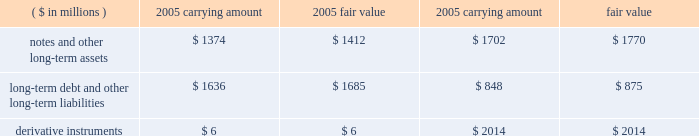Fair value of financial instruments we believe that the fair values of current assets and current liabilities approximate their reported carrying amounts .
The fair values of non-current financial assets , liabilities and derivatives are shown in the table. .
We value notes and other receivables based on the expected future cash flows dis- counted at risk-adjusted rates .
We determine valuations for long-term debt and other long-term liabilities based on quoted market prices or expected future payments dis- counted at risk-adjusted rates .
Derivative instruments during 2003 , we entered into an interest rate swap agreement under which we receive a floating rate of interest and pay a fixed rate of interest .
The swap modifies our interest rate exposure by effectively converting a note receivable with a fixed rate to a floating rate .
The aggregate notional amount of the swap is $ 92 million and it matures in 2010 .
The swap is classified as a fair value hedge under fas no .
133 , 201caccounting for derivative instruments and hedging activities 201d ( 201cfas no .
133 201d ) , and the change in the fair value of the swap , as well as the change in the fair value of the underlying note receivable , is recognized in interest income .
The fair value of the swap was a $ 1 million asset at year-end 2005 , and a $ 3 million liability at year-end 2004 .
The hedge is highly effective , and therefore , no net gain or loss was reported during 2005 , 2004 , and 2003 .
During 2005 , we entered into two interest rate swap agreements to manage the volatil- ity of the u.s .
Treasury component of the interest rate risk associated with the forecasted issuance our series f senior notes and the exchange of our series c and e senior notes for new series g senior notes .
Both swaps were designated as cash flow hedges under fas no .
133 and were terminated upon pricing of the notes .
Both swaps were highly effective in offsetting fluctuations in the u.s .
Treasury component .
Thus , there was no net gain or loss reported in earnings during 2005 .
The total amount for these swaps was recorded in other comprehensive income and was a net loss of $ 2 million during 2005 , which will be amortized to interest expense using the interest method over the life of the notes .
At year-end 2005 , we had six outstanding interest rate swap agreements to manage interest rate risk associated with the residual interests we retain in conjunction with our timeshare note sales .
Historically , we were required by purchasers and/or rating agen- cies to utilize interest rate swaps to protect the excess spread within our sold note pools .
The aggregate notional amount of the swaps is $ 380 million , and they expire through 2022 .
These swaps are not accounted for as hedges under fas no .
133 .
The fair value of the swaps is a net asset of $ 5 million at year-end 2005 , and a net asset of approximately $ 3 million at year-end 2004 .
We recorded a $ 2 million net gain during 2005 and 2004 , and a $ 3 million net gain during 2003 .
During 2005 , 2004 , and 2003 , we entered into interest rate swaps to manage interest rate risk associated with forecasted timeshare note sales .
During 2005 , one swap was designated as a cash flow hedge under fas no .
133 and was highly effective in offsetting interest rate fluctuations .
The amount of the ineffectiveness is immaterial .
The second swap entered into in 2005 did not qualify for hedge accounting .
The non-qualifying swaps resulted in a loss of $ 3 million during 2005 , a gain of $ 2 million during 2004 and a loss of $ 4 million during 2003 .
These amounts are included in the gains from the sales of timeshare notes receivable .
During 2005 , 2004 , and 2003 , we entered into forward foreign exchange contracts to manage the foreign currency exposure related to certain monetary assets .
The aggregate dollar equivalent of the notional amount of the contracts is $ 544 million at year-end 2005 .
The forward exchange contracts do not qualify as hedges in accordance with fas no .
133 .
The fair value of the forward contracts is a liability of $ 2 million at year-end 2005 and zero at year-end 2004 .
We recorded a $ 26 million gain during 2005 and a $ 3 million and $ 2 million net loss during 2004 and 2003 , respectively , relating to these forward foreign exchange contracts .
The net gains and losses for all years were offset by income and losses recorded from translating the related monetary assets denominated in foreign currencies into u.s .
Dollars .
During 2005 , 2004 , and 2003 , we entered into foreign exchange option and forward contracts to hedge the potential volatility of earnings and cash flows associated with variations in foreign exchange rates .
The aggregate dollar equivalent of the notional amounts of the contracts is $ 27 million at year-end 2005 .
These contracts have terms of less than one year and are classified as cash flow hedges .
Changes in their fair values are recorded as a component of other comprehensive income .
The fair value of the option contracts is approximately zero at year-end 2005 and 2004 .
During 2004 , it was deter- mined that certain derivatives were no longer effective in offsetting the hedged item .
Thus , cash flow hedge accounting treatment was discontinued and the ineffective con- tracts resulted in a loss of $ 1 million , which was reported in earnings for 2004 .
The remaining hedges were highly effective and there was no net gain or loss reported in earnings for 2005 , 2004 , and 2003 .
As of year-end 2005 , there were no deferred gains or losses on existing contracts accumulated in other comprehensive income that we expect to reclassify into earnings over the next year .
During 2005 , we entered into forward foreign exchange contracts to manage currency exchange rate volatility associated with certain investments in foreign operations .
One contract was designated as a hedge in the net investment of a foreign operation under fas no .
133 .
The hedge was highly effective and resulted in a $ 1 million net loss in the cumulative translation adjustment at year-end 2005 .
Certain contracts did not qualify as hedges under fas no .
133 and resulted in a gain of $ 3 million for 2005 .
The contracts offset the losses associated with translation adjustments for various investments in for- eign operations .
The contracts have an aggregate dollar equivalent of the notional amounts of $ 229 million and a fair value of approximately zero at year-end 2005 .
Contingencies guarantees we issue guarantees to certain lenders and hotel owners primarily to obtain long-term management contracts .
The guarantees generally have a stated maximum amount of funding and a term of five years or less .
The terms of guarantees to lenders generally require us to fund if cash flows from hotel operations are inadequate to cover annual debt service or to repay the loan at the end of the term .
The terms of the guarantees to hotel owners generally require us to fund if the hotels do not attain specified levels of 5 0 | m a r r i o t t i n t e r n a t i o n a l , i n c .
2 0 0 5 .
What is the potential gain if the notes and other long-term assets had been sold at the end of 2005? 
Rationale: this represents an un realized asset on the balance sheet and would be a gain to the company if sold at fair value .
Computations: (1412 - 1374)
Answer: 38.0. 